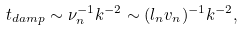Convert formula to latex. <formula><loc_0><loc_0><loc_500><loc_500>t _ { d a m p } \sim \nu _ { n } ^ { - 1 } k ^ { - 2 } \sim ( l _ { n } v _ { n } ) ^ { - 1 } k ^ { - 2 } ,</formula> 